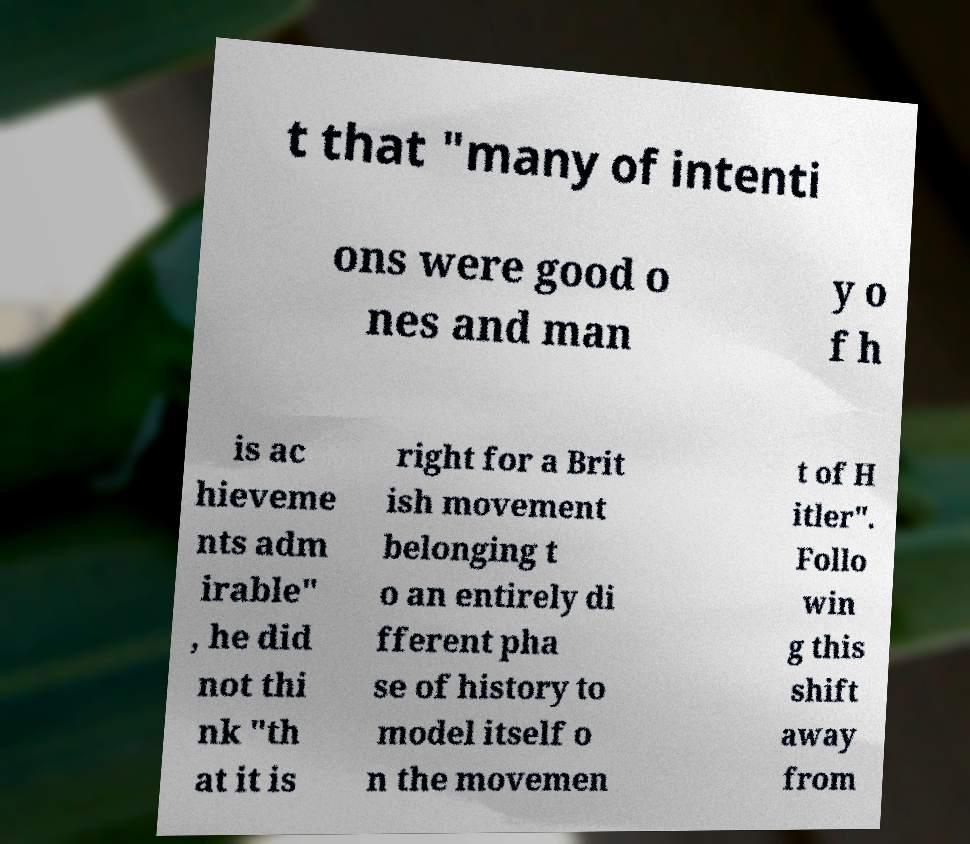Can you read and provide the text displayed in the image?This photo seems to have some interesting text. Can you extract and type it out for me? t that "many of intenti ons were good o nes and man y o f h is ac hieveme nts adm irable" , he did not thi nk "th at it is right for a Brit ish movement belonging t o an entirely di fferent pha se of history to model itself o n the movemen t of H itler". Follo win g this shift away from 